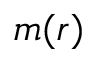<formula> <loc_0><loc_0><loc_500><loc_500>m ( r )</formula> 